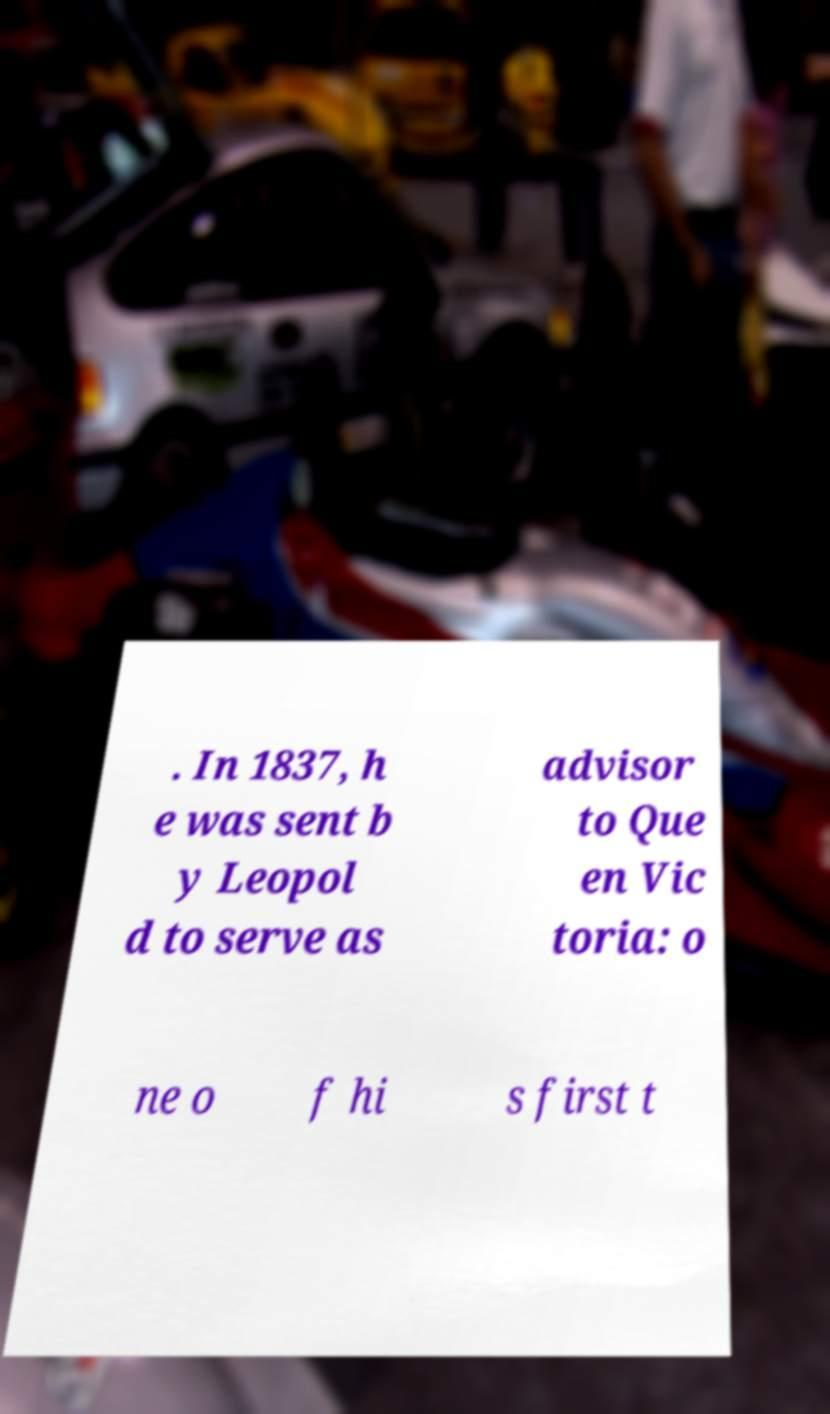Please identify and transcribe the text found in this image. . In 1837, h e was sent b y Leopol d to serve as advisor to Que en Vic toria: o ne o f hi s first t 